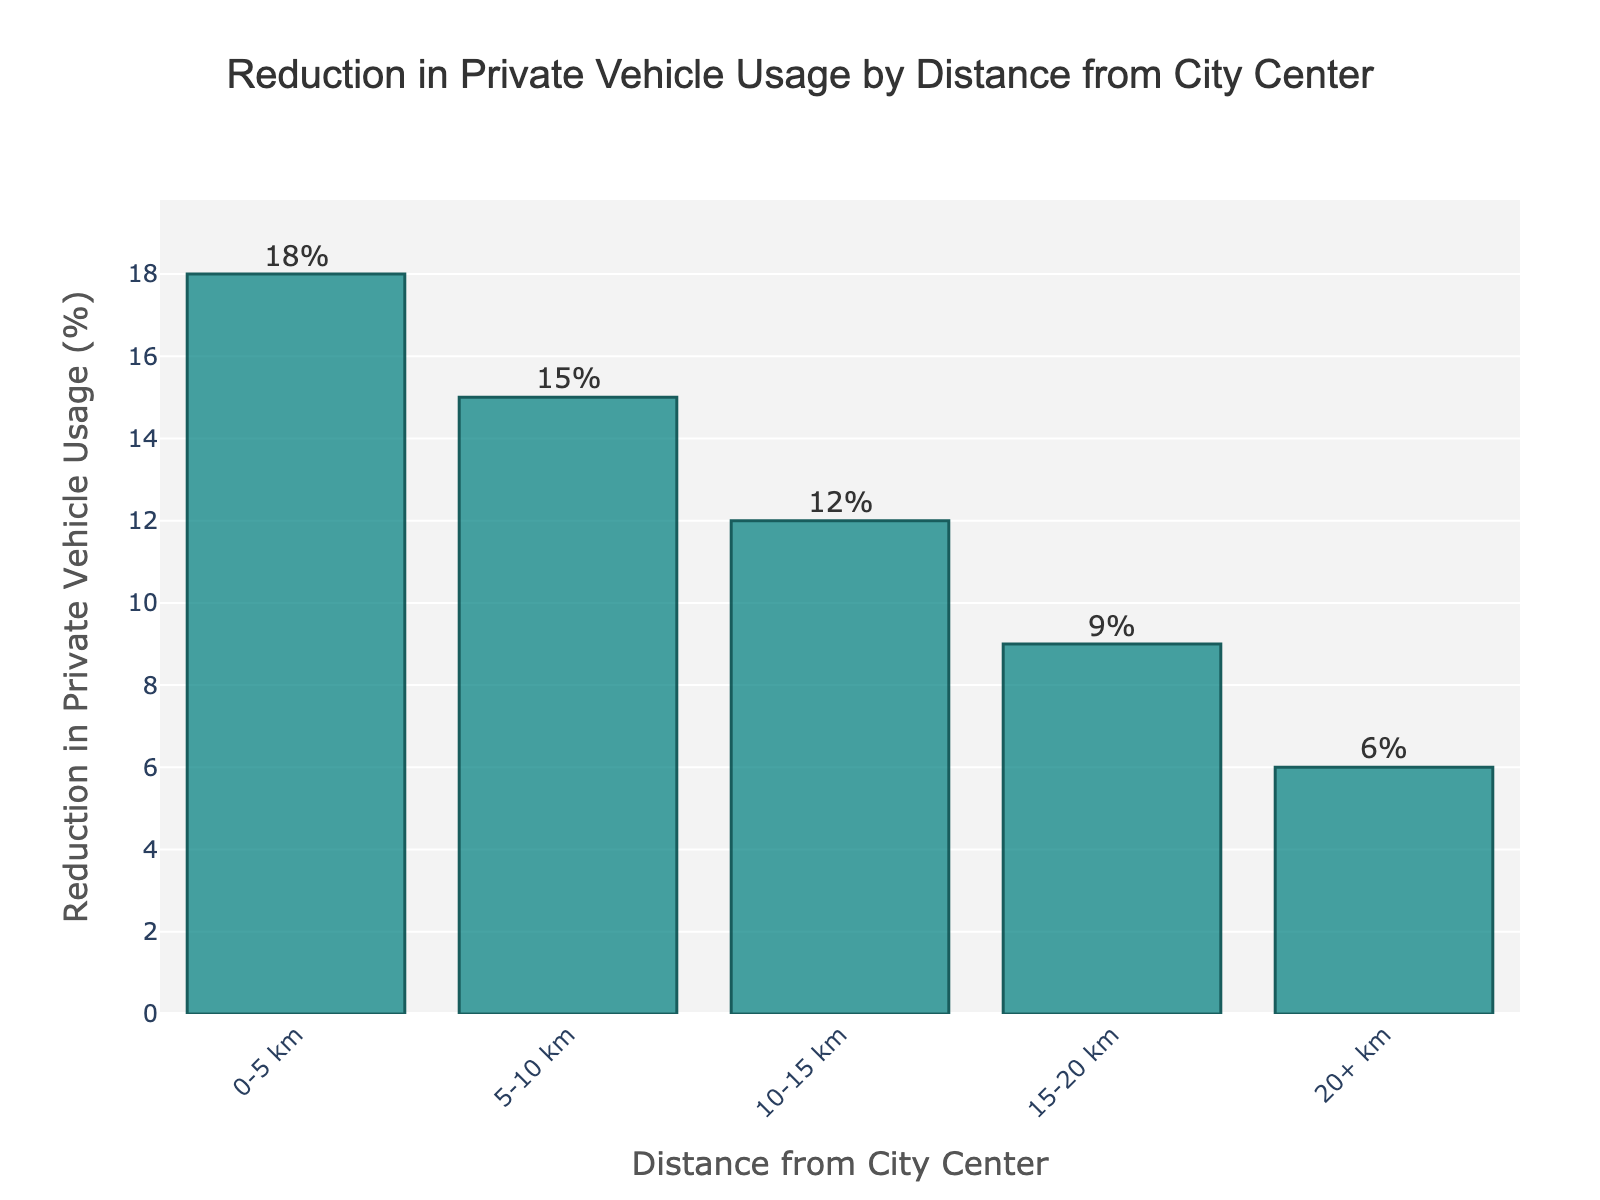Which distance category from the city center sees the greatest reduction in private vehicle usage? To identify the category with the greatest reduction, look at the bar representing the highest percentage on the y-axis. The category "0-5 km" shows an 18% reduction, which is the highest in the dataset.
Answer: 0-5 km What is the difference in reduction percentages between the 0-5 km and 20+ km categories? To find the difference, subtract the reduction percentage of the 20+ km category from the 0-5 km category. The difference is 18% - 6% = 12%.
Answer: 12% Compare the reduction percentages of the categories 10-15 km and 15-20 km. By inspecting the heights of their respective bars, the 10-15 km category shows a 12% reduction, while the 15-20 km category shows a 9% reduction. Thus, 10-15 km has a higher reduction.
Answer: 10-15 km What is the average reduction in private vehicle usage across all distance categories? To calculate the average, sum up all the percentages and divide by the number of categories: (18% + 15% + 12% + 9% + 6%) / 5 = 12%.
Answer: 12% If we consider only the outer areas (15-20 km and 20+ km), what is their combined reduction percentage? Sum the reductions for the 15-20 km and 20+ km categories: 9% + 6% = 15%.
Answer: 15% What range does the y-axis cover in this chart? The y-axis starts from 0% and extends slightly above the highest value (18%), so it ranges from 0% to approximately 20%.
Answer: 0% to 20% Which distance category had the lowest reduction in vehicle usage? The bar representing the 20+ km category has the lowest height, indicating a 6% reduction, which is the smallest in the dataset.
Answer: 20+ km How much more reduction is observed in the 5-10 km category compared to the 15-20 km category? Subtract the reduction percentage of the 15-20 km category from the 5-10 km category: 15% - 9% = 6%.
Answer: 6% What is the average reduction in private vehicle usage for the intermediate distances (5-10 km and 10-15 km)? Calculate the average by summing up the reductions for 5-10 km and 10-15 km, then dividing by the number of these categories: (15% + 12%) / 2 = 13.5%.
Answer: 13.5% By looking at the bars, how is the reduction in vehicle usage trend as the distance increases from the city center? The height of the bars decreases as the distance from the city center increases, indicating a downward trend in the reduction of private vehicle usage.
Answer: Downward Trend 